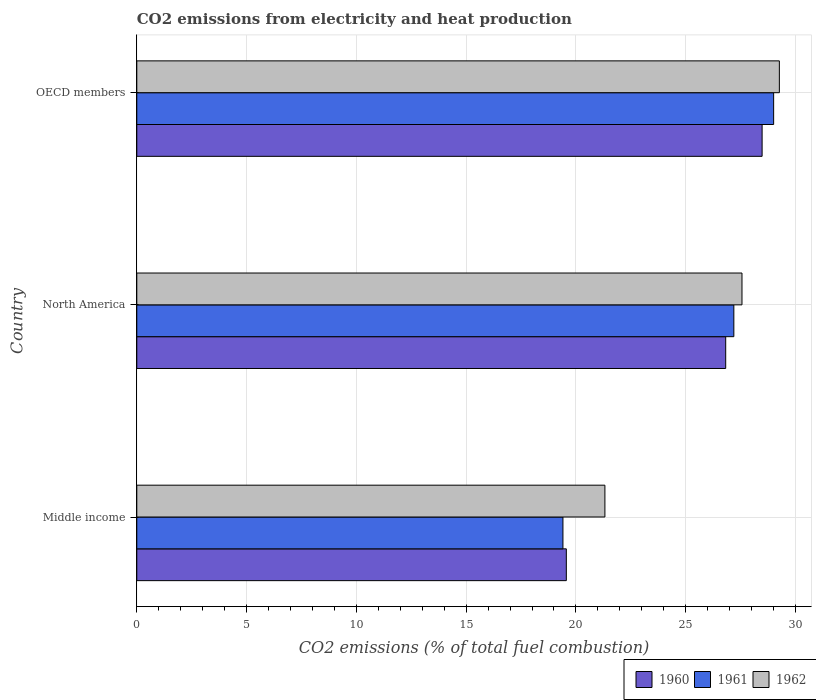How many different coloured bars are there?
Make the answer very short. 3. Are the number of bars on each tick of the Y-axis equal?
Make the answer very short. Yes. How many bars are there on the 3rd tick from the top?
Your response must be concise. 3. How many bars are there on the 2nd tick from the bottom?
Provide a succinct answer. 3. What is the label of the 3rd group of bars from the top?
Keep it short and to the point. Middle income. What is the amount of CO2 emitted in 1960 in OECD members?
Offer a terse response. 28.48. Across all countries, what is the maximum amount of CO2 emitted in 1961?
Your answer should be compact. 29. Across all countries, what is the minimum amount of CO2 emitted in 1961?
Provide a short and direct response. 19.41. What is the total amount of CO2 emitted in 1962 in the graph?
Your answer should be compact. 78.15. What is the difference between the amount of CO2 emitted in 1960 in Middle income and that in OECD members?
Provide a succinct answer. -8.92. What is the difference between the amount of CO2 emitted in 1960 in Middle income and the amount of CO2 emitted in 1961 in OECD members?
Offer a terse response. -9.44. What is the average amount of CO2 emitted in 1961 per country?
Provide a short and direct response. 25.2. What is the difference between the amount of CO2 emitted in 1962 and amount of CO2 emitted in 1961 in North America?
Your answer should be compact. 0.37. What is the ratio of the amount of CO2 emitted in 1961 in North America to that in OECD members?
Your response must be concise. 0.94. Is the amount of CO2 emitted in 1962 in North America less than that in OECD members?
Your answer should be compact. Yes. What is the difference between the highest and the second highest amount of CO2 emitted in 1961?
Make the answer very short. 1.81. What is the difference between the highest and the lowest amount of CO2 emitted in 1961?
Your answer should be compact. 9.6. Is the sum of the amount of CO2 emitted in 1962 in Middle income and North America greater than the maximum amount of CO2 emitted in 1961 across all countries?
Give a very brief answer. Yes. What is the difference between two consecutive major ticks on the X-axis?
Provide a succinct answer. 5. Does the graph contain any zero values?
Make the answer very short. No. Does the graph contain grids?
Give a very brief answer. Yes. How many legend labels are there?
Offer a terse response. 3. How are the legend labels stacked?
Keep it short and to the point. Horizontal. What is the title of the graph?
Provide a succinct answer. CO2 emissions from electricity and heat production. Does "1977" appear as one of the legend labels in the graph?
Offer a terse response. No. What is the label or title of the X-axis?
Provide a short and direct response. CO2 emissions (% of total fuel combustion). What is the CO2 emissions (% of total fuel combustion) in 1960 in Middle income?
Make the answer very short. 19.56. What is the CO2 emissions (% of total fuel combustion) in 1961 in Middle income?
Give a very brief answer. 19.41. What is the CO2 emissions (% of total fuel combustion) of 1962 in Middle income?
Give a very brief answer. 21.32. What is the CO2 emissions (% of total fuel combustion) of 1960 in North America?
Ensure brevity in your answer.  26.82. What is the CO2 emissions (% of total fuel combustion) in 1961 in North America?
Ensure brevity in your answer.  27.19. What is the CO2 emissions (% of total fuel combustion) in 1962 in North America?
Ensure brevity in your answer.  27.56. What is the CO2 emissions (% of total fuel combustion) of 1960 in OECD members?
Your answer should be very brief. 28.48. What is the CO2 emissions (% of total fuel combustion) of 1961 in OECD members?
Ensure brevity in your answer.  29. What is the CO2 emissions (% of total fuel combustion) of 1962 in OECD members?
Offer a terse response. 29.26. Across all countries, what is the maximum CO2 emissions (% of total fuel combustion) in 1960?
Make the answer very short. 28.48. Across all countries, what is the maximum CO2 emissions (% of total fuel combustion) of 1961?
Give a very brief answer. 29. Across all countries, what is the maximum CO2 emissions (% of total fuel combustion) in 1962?
Your response must be concise. 29.26. Across all countries, what is the minimum CO2 emissions (% of total fuel combustion) in 1960?
Give a very brief answer. 19.56. Across all countries, what is the minimum CO2 emissions (% of total fuel combustion) of 1961?
Keep it short and to the point. 19.41. Across all countries, what is the minimum CO2 emissions (% of total fuel combustion) of 1962?
Keep it short and to the point. 21.32. What is the total CO2 emissions (% of total fuel combustion) in 1960 in the graph?
Offer a terse response. 74.86. What is the total CO2 emissions (% of total fuel combustion) of 1961 in the graph?
Your answer should be very brief. 75.6. What is the total CO2 emissions (% of total fuel combustion) of 1962 in the graph?
Ensure brevity in your answer.  78.15. What is the difference between the CO2 emissions (% of total fuel combustion) of 1960 in Middle income and that in North America?
Offer a very short reply. -7.26. What is the difference between the CO2 emissions (% of total fuel combustion) in 1961 in Middle income and that in North America?
Make the answer very short. -7.78. What is the difference between the CO2 emissions (% of total fuel combustion) of 1962 in Middle income and that in North America?
Your answer should be compact. -6.24. What is the difference between the CO2 emissions (% of total fuel combustion) in 1960 in Middle income and that in OECD members?
Your response must be concise. -8.92. What is the difference between the CO2 emissions (% of total fuel combustion) in 1961 in Middle income and that in OECD members?
Provide a short and direct response. -9.6. What is the difference between the CO2 emissions (% of total fuel combustion) of 1962 in Middle income and that in OECD members?
Your answer should be compact. -7.95. What is the difference between the CO2 emissions (% of total fuel combustion) of 1960 in North America and that in OECD members?
Offer a very short reply. -1.66. What is the difference between the CO2 emissions (% of total fuel combustion) of 1961 in North America and that in OECD members?
Offer a very short reply. -1.81. What is the difference between the CO2 emissions (% of total fuel combustion) of 1962 in North America and that in OECD members?
Keep it short and to the point. -1.7. What is the difference between the CO2 emissions (% of total fuel combustion) of 1960 in Middle income and the CO2 emissions (% of total fuel combustion) of 1961 in North America?
Provide a short and direct response. -7.63. What is the difference between the CO2 emissions (% of total fuel combustion) in 1960 in Middle income and the CO2 emissions (% of total fuel combustion) in 1962 in North America?
Offer a terse response. -8. What is the difference between the CO2 emissions (% of total fuel combustion) of 1961 in Middle income and the CO2 emissions (% of total fuel combustion) of 1962 in North America?
Make the answer very short. -8.15. What is the difference between the CO2 emissions (% of total fuel combustion) of 1960 in Middle income and the CO2 emissions (% of total fuel combustion) of 1961 in OECD members?
Offer a terse response. -9.44. What is the difference between the CO2 emissions (% of total fuel combustion) in 1960 in Middle income and the CO2 emissions (% of total fuel combustion) in 1962 in OECD members?
Make the answer very short. -9.7. What is the difference between the CO2 emissions (% of total fuel combustion) of 1961 in Middle income and the CO2 emissions (% of total fuel combustion) of 1962 in OECD members?
Ensure brevity in your answer.  -9.86. What is the difference between the CO2 emissions (% of total fuel combustion) of 1960 in North America and the CO2 emissions (% of total fuel combustion) of 1961 in OECD members?
Give a very brief answer. -2.18. What is the difference between the CO2 emissions (% of total fuel combustion) of 1960 in North America and the CO2 emissions (% of total fuel combustion) of 1962 in OECD members?
Provide a short and direct response. -2.44. What is the difference between the CO2 emissions (% of total fuel combustion) of 1961 in North America and the CO2 emissions (% of total fuel combustion) of 1962 in OECD members?
Offer a very short reply. -2.07. What is the average CO2 emissions (% of total fuel combustion) of 1960 per country?
Your response must be concise. 24.95. What is the average CO2 emissions (% of total fuel combustion) in 1961 per country?
Offer a terse response. 25.2. What is the average CO2 emissions (% of total fuel combustion) of 1962 per country?
Keep it short and to the point. 26.05. What is the difference between the CO2 emissions (% of total fuel combustion) of 1960 and CO2 emissions (% of total fuel combustion) of 1961 in Middle income?
Provide a succinct answer. 0.15. What is the difference between the CO2 emissions (% of total fuel combustion) of 1960 and CO2 emissions (% of total fuel combustion) of 1962 in Middle income?
Your response must be concise. -1.76. What is the difference between the CO2 emissions (% of total fuel combustion) in 1961 and CO2 emissions (% of total fuel combustion) in 1962 in Middle income?
Provide a succinct answer. -1.91. What is the difference between the CO2 emissions (% of total fuel combustion) in 1960 and CO2 emissions (% of total fuel combustion) in 1961 in North America?
Your answer should be compact. -0.37. What is the difference between the CO2 emissions (% of total fuel combustion) of 1960 and CO2 emissions (% of total fuel combustion) of 1962 in North America?
Provide a succinct answer. -0.74. What is the difference between the CO2 emissions (% of total fuel combustion) of 1961 and CO2 emissions (% of total fuel combustion) of 1962 in North America?
Provide a succinct answer. -0.37. What is the difference between the CO2 emissions (% of total fuel combustion) of 1960 and CO2 emissions (% of total fuel combustion) of 1961 in OECD members?
Provide a succinct answer. -0.52. What is the difference between the CO2 emissions (% of total fuel combustion) in 1960 and CO2 emissions (% of total fuel combustion) in 1962 in OECD members?
Give a very brief answer. -0.79. What is the difference between the CO2 emissions (% of total fuel combustion) of 1961 and CO2 emissions (% of total fuel combustion) of 1962 in OECD members?
Give a very brief answer. -0.26. What is the ratio of the CO2 emissions (% of total fuel combustion) of 1960 in Middle income to that in North America?
Your answer should be compact. 0.73. What is the ratio of the CO2 emissions (% of total fuel combustion) in 1961 in Middle income to that in North America?
Your answer should be very brief. 0.71. What is the ratio of the CO2 emissions (% of total fuel combustion) of 1962 in Middle income to that in North America?
Your answer should be compact. 0.77. What is the ratio of the CO2 emissions (% of total fuel combustion) in 1960 in Middle income to that in OECD members?
Your response must be concise. 0.69. What is the ratio of the CO2 emissions (% of total fuel combustion) in 1961 in Middle income to that in OECD members?
Your answer should be very brief. 0.67. What is the ratio of the CO2 emissions (% of total fuel combustion) of 1962 in Middle income to that in OECD members?
Provide a succinct answer. 0.73. What is the ratio of the CO2 emissions (% of total fuel combustion) in 1960 in North America to that in OECD members?
Your response must be concise. 0.94. What is the ratio of the CO2 emissions (% of total fuel combustion) of 1961 in North America to that in OECD members?
Your answer should be compact. 0.94. What is the ratio of the CO2 emissions (% of total fuel combustion) of 1962 in North America to that in OECD members?
Offer a terse response. 0.94. What is the difference between the highest and the second highest CO2 emissions (% of total fuel combustion) of 1960?
Provide a succinct answer. 1.66. What is the difference between the highest and the second highest CO2 emissions (% of total fuel combustion) in 1961?
Your answer should be compact. 1.81. What is the difference between the highest and the second highest CO2 emissions (% of total fuel combustion) of 1962?
Offer a very short reply. 1.7. What is the difference between the highest and the lowest CO2 emissions (% of total fuel combustion) in 1960?
Make the answer very short. 8.92. What is the difference between the highest and the lowest CO2 emissions (% of total fuel combustion) in 1961?
Your answer should be very brief. 9.6. What is the difference between the highest and the lowest CO2 emissions (% of total fuel combustion) of 1962?
Offer a terse response. 7.95. 